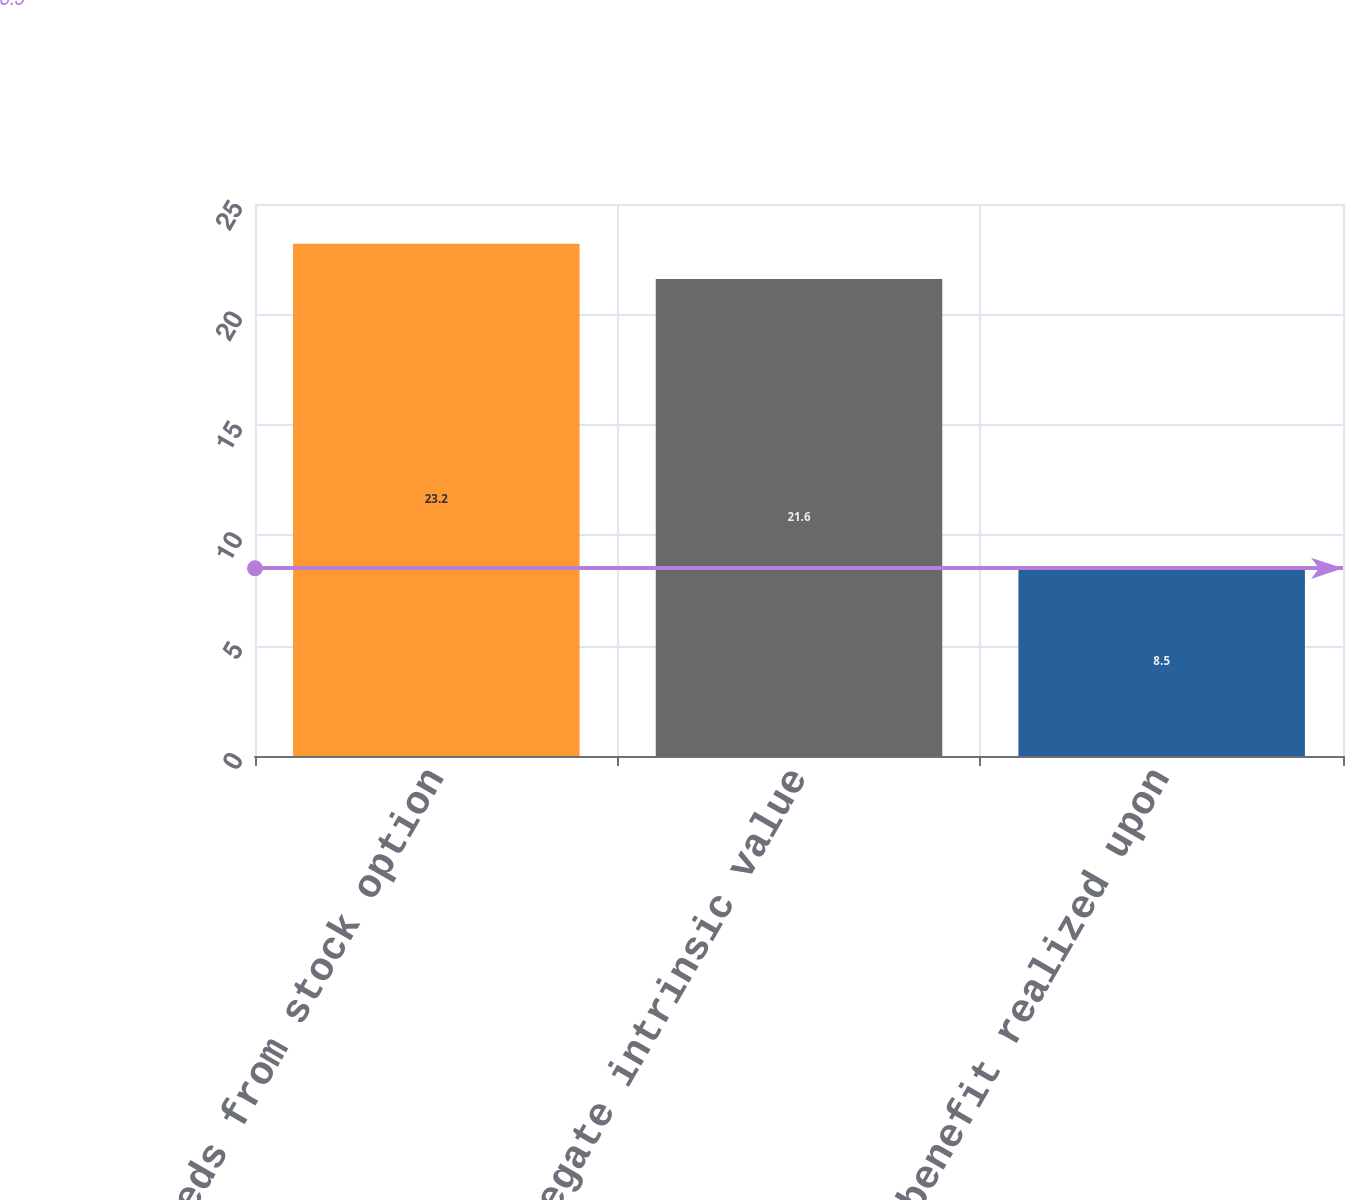Convert chart. <chart><loc_0><loc_0><loc_500><loc_500><bar_chart><fcel>Proceeds from stock option<fcel>Aggregate intrinsic value<fcel>Tax benefit realized upon<nl><fcel>23.2<fcel>21.6<fcel>8.5<nl></chart> 